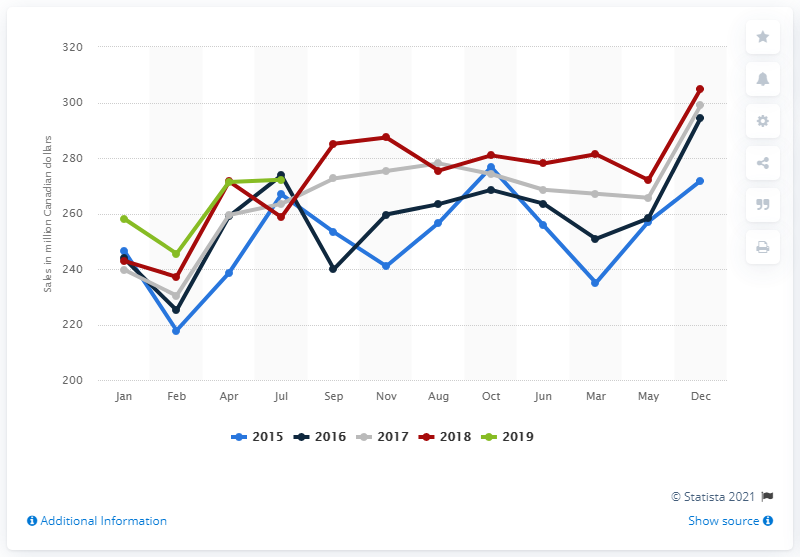Mention a couple of crucial points in this snapshot. Between 2015 and 2018, the average monthly sales of bakery products in Canada were approximately 271.82. In April 2019, the retail sales of bakery products in Canada were 271.82 million units. 